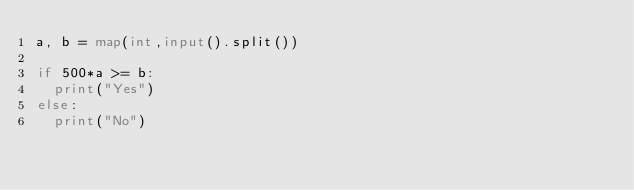Convert code to text. <code><loc_0><loc_0><loc_500><loc_500><_Python_>a, b = map(int,input().split())

if 500*a >= b:
  print("Yes")
else:
  print("No")</code> 